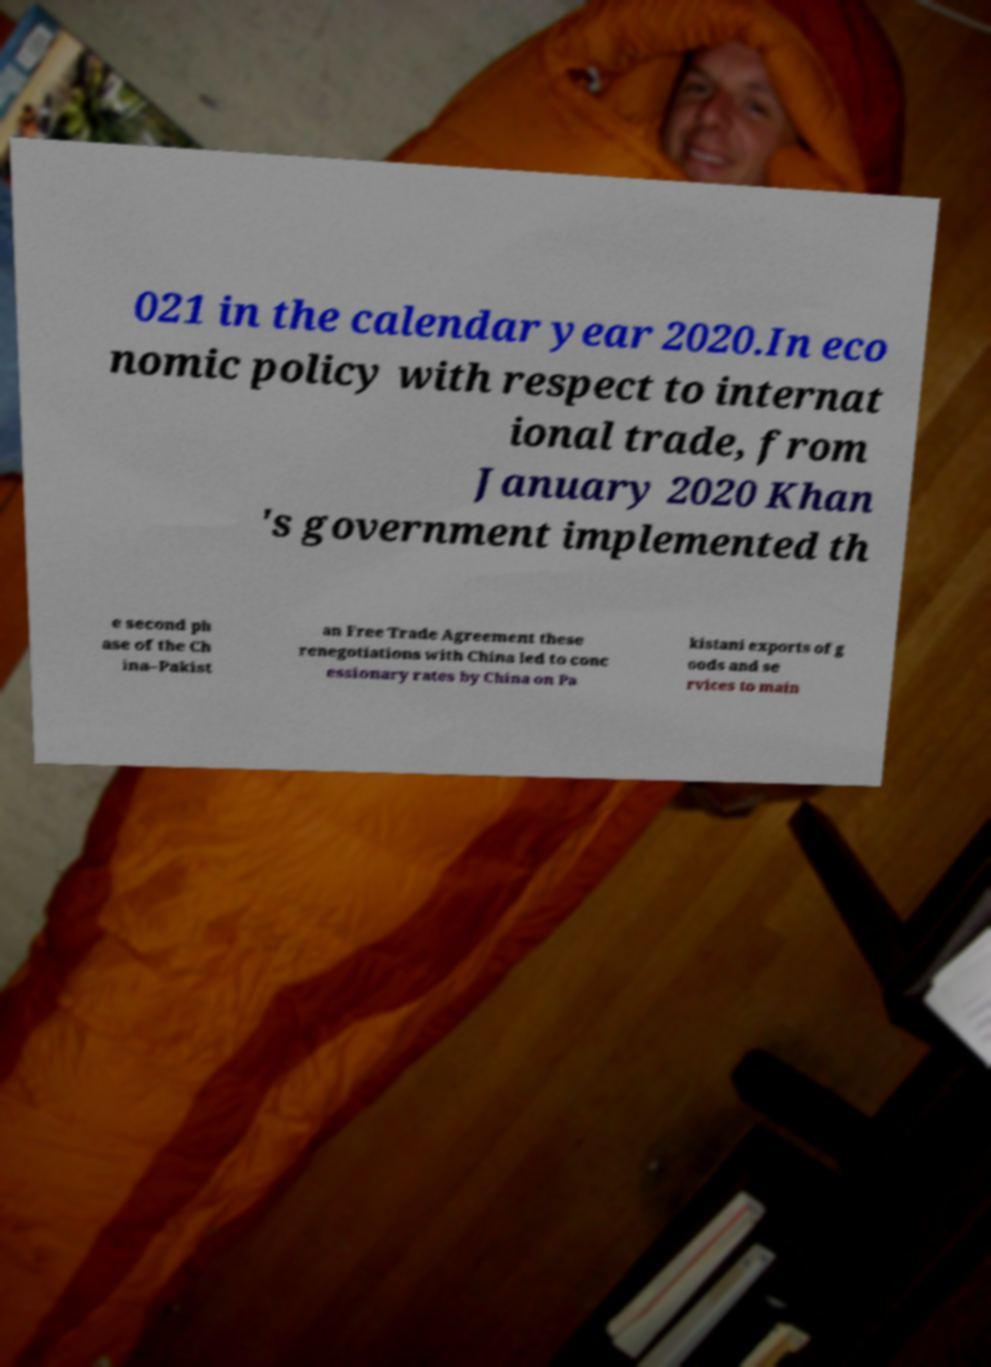There's text embedded in this image that I need extracted. Can you transcribe it verbatim? 021 in the calendar year 2020.In eco nomic policy with respect to internat ional trade, from January 2020 Khan 's government implemented th e second ph ase of the Ch ina–Pakist an Free Trade Agreement these renegotiations with China led to conc essionary rates by China on Pa kistani exports of g oods and se rvices to main 